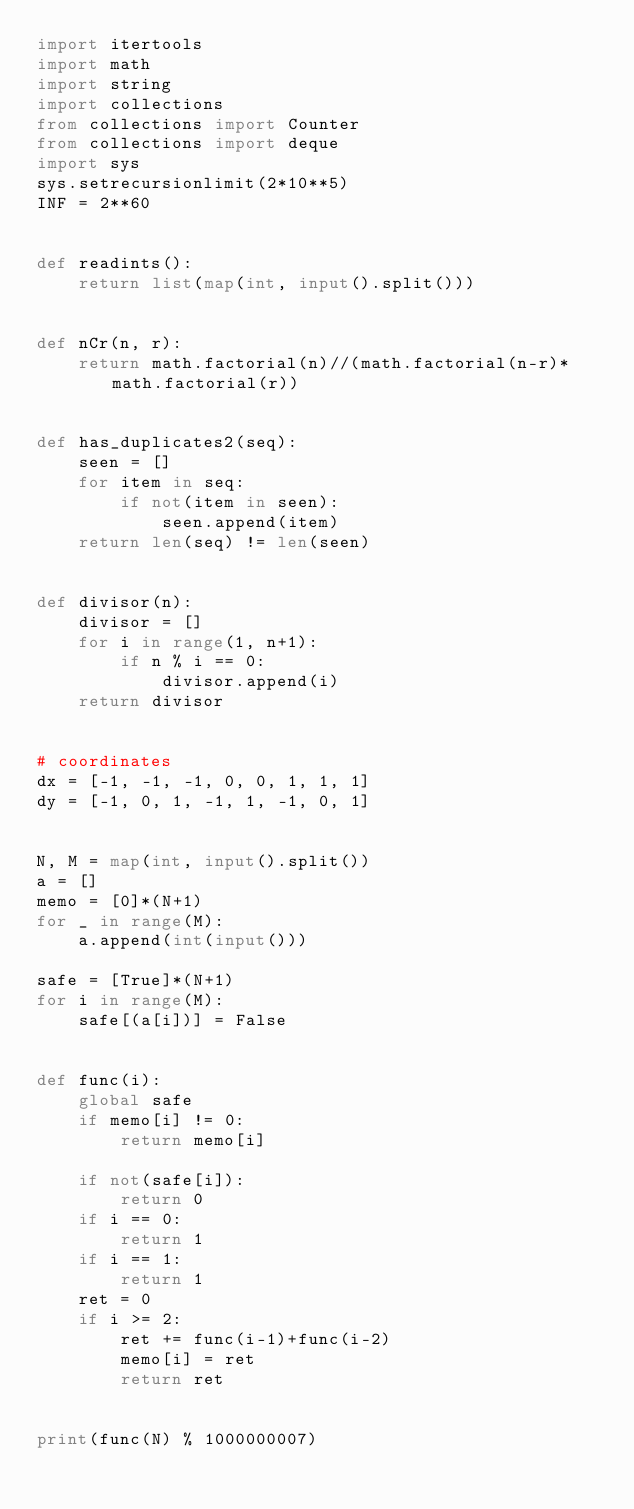Convert code to text. <code><loc_0><loc_0><loc_500><loc_500><_Python_>import itertools
import math
import string
import collections
from collections import Counter
from collections import deque
import sys
sys.setrecursionlimit(2*10**5)
INF = 2**60


def readints():
    return list(map(int, input().split()))


def nCr(n, r):
    return math.factorial(n)//(math.factorial(n-r)*math.factorial(r))


def has_duplicates2(seq):
    seen = []
    for item in seq:
        if not(item in seen):
            seen.append(item)
    return len(seq) != len(seen)


def divisor(n):
    divisor = []
    for i in range(1, n+1):
        if n % i == 0:
            divisor.append(i)
    return divisor


# coordinates
dx = [-1, -1, -1, 0, 0, 1, 1, 1]
dy = [-1, 0, 1, -1, 1, -1, 0, 1]


N, M = map(int, input().split())
a = []
memo = [0]*(N+1)
for _ in range(M):
    a.append(int(input()))

safe = [True]*(N+1)
for i in range(M):
    safe[(a[i])] = False


def func(i):
    global safe
    if memo[i] != 0:
        return memo[i]

    if not(safe[i]):
        return 0
    if i == 0:
        return 1
    if i == 1:
        return 1
    ret = 0
    if i >= 2:
        ret += func(i-1)+func(i-2)
        memo[i] = ret
        return ret


print(func(N) % 1000000007)
</code> 